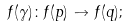Convert formula to latex. <formula><loc_0><loc_0><loc_500><loc_500>f ( \gamma ) \colon f ( p ) \to f ( q ) ;</formula> 